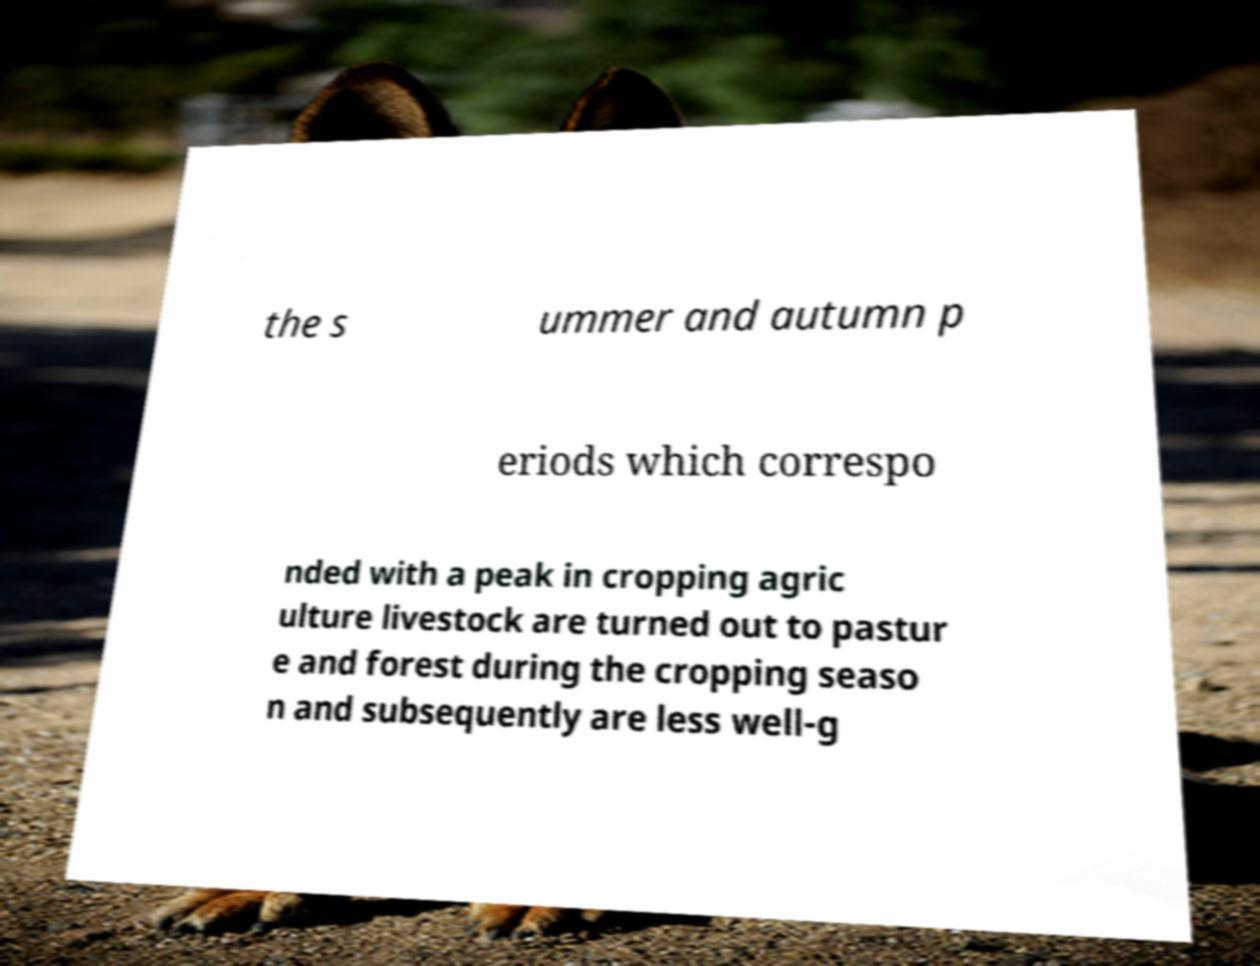What messages or text are displayed in this image? I need them in a readable, typed format. the s ummer and autumn p eriods which correspo nded with a peak in cropping agric ulture livestock are turned out to pastur e and forest during the cropping seaso n and subsequently are less well-g 